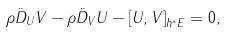Convert formula to latex. <formula><loc_0><loc_0><loc_500><loc_500>\rho \ddot { D } _ { U } V - \rho \ddot { D } _ { V } U - \left [ U , V \right ] _ { h ^ { \ast } E } = 0 ,</formula> 